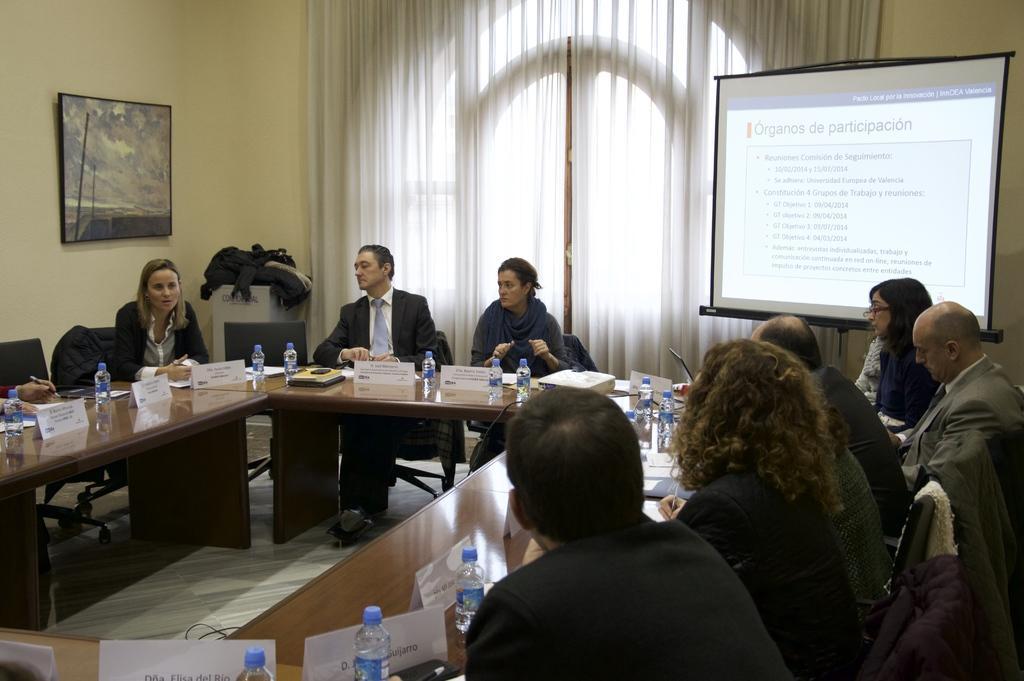Could you give a brief overview of what you see in this image? There are some persons sitting on the chairs. This is table. On the table there are bottles, and a book. In the background there is a wall and this is curtain. Here we can see a screen and there is a frame. 